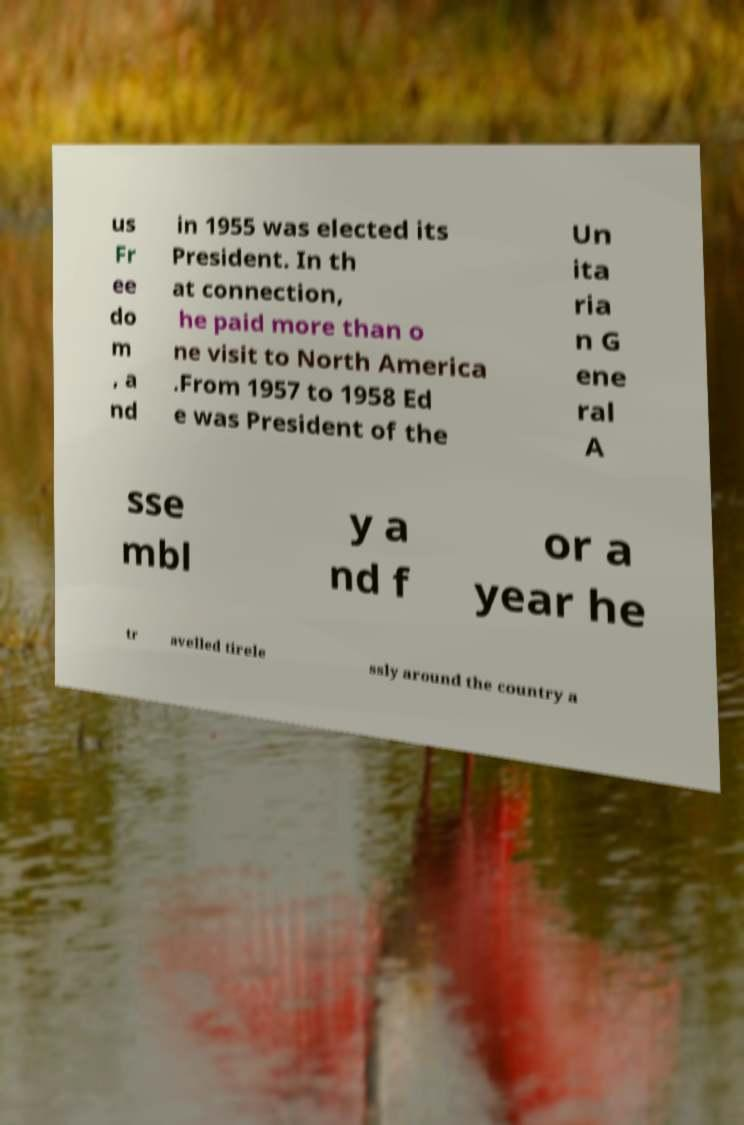There's text embedded in this image that I need extracted. Can you transcribe it verbatim? us Fr ee do m , a nd in 1955 was elected its President. In th at connection, he paid more than o ne visit to North America .From 1957 to 1958 Ed e was President of the Un ita ria n G ene ral A sse mbl y a nd f or a year he tr avelled tirele ssly around the country a 